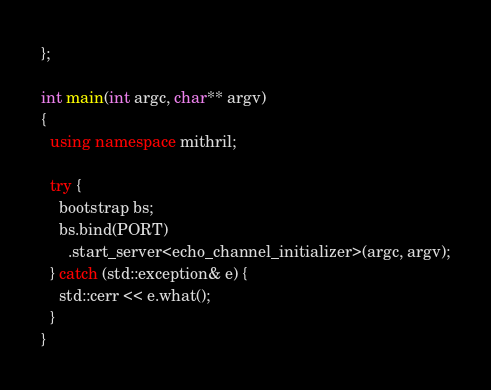Convert code to text. <code><loc_0><loc_0><loc_500><loc_500><_C++_>};

int main(int argc, char** argv)
{
  using namespace mithril;

  try {
    bootstrap bs;
    bs.bind(PORT)
      .start_server<echo_channel_initializer>(argc, argv);
  } catch (std::exception& e) {
    std::cerr << e.what();
  }
}</code> 